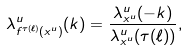<formula> <loc_0><loc_0><loc_500><loc_500>\lambda ^ { u } _ { f ^ { \tau ( \ell ) } ( x ^ { u } ) } ( k ) = \frac { \lambda ^ { u } _ { x ^ { u } } ( - k ) } { \lambda ^ { u } _ { x ^ { u } } ( \tau ( \ell ) ) } ,</formula> 